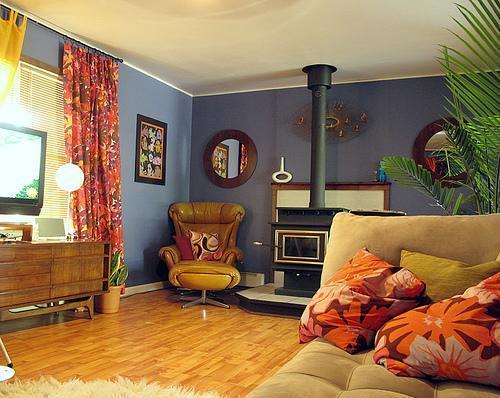How many knives are here?
Give a very brief answer. 0. 